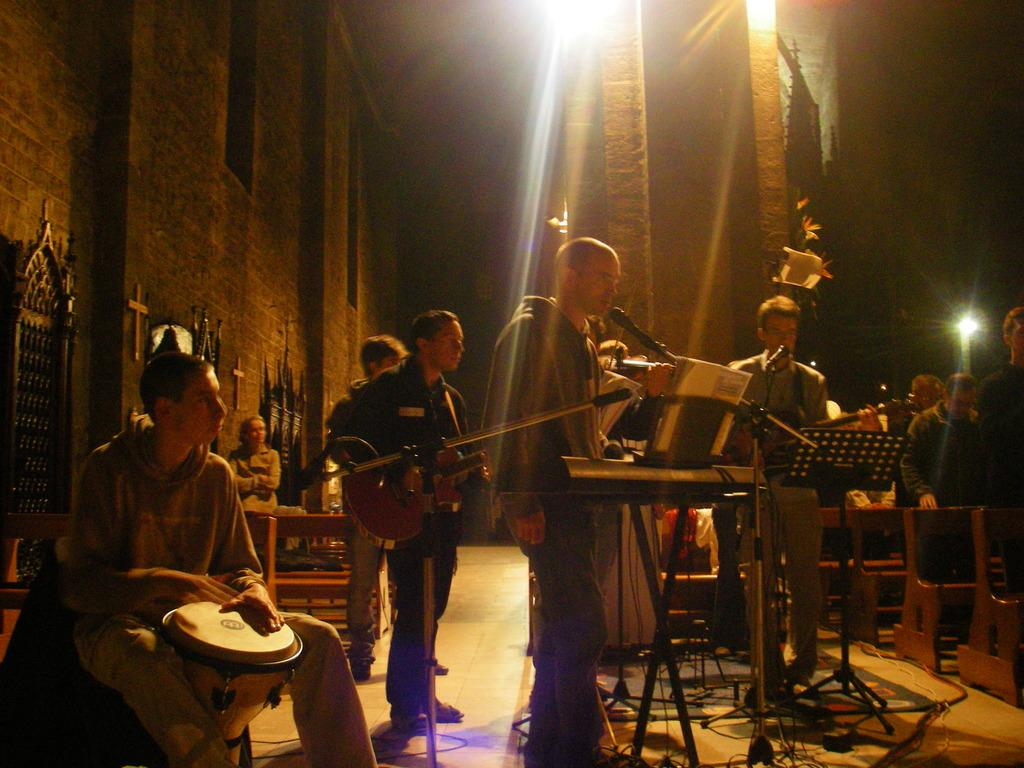What type of group is present in the image? There is a band of musicians in the image. What are the musicians doing in the image? The musicians are playing music. Can you describe the setting of the image? The setting appears to be a concert. What type of paste is being used by the musicians in the image? There is no paste present in the image; the musicians are playing music. Can you see any cows in the image? There are no cows present in the image; it features a band of musicians playing music at a concert. 